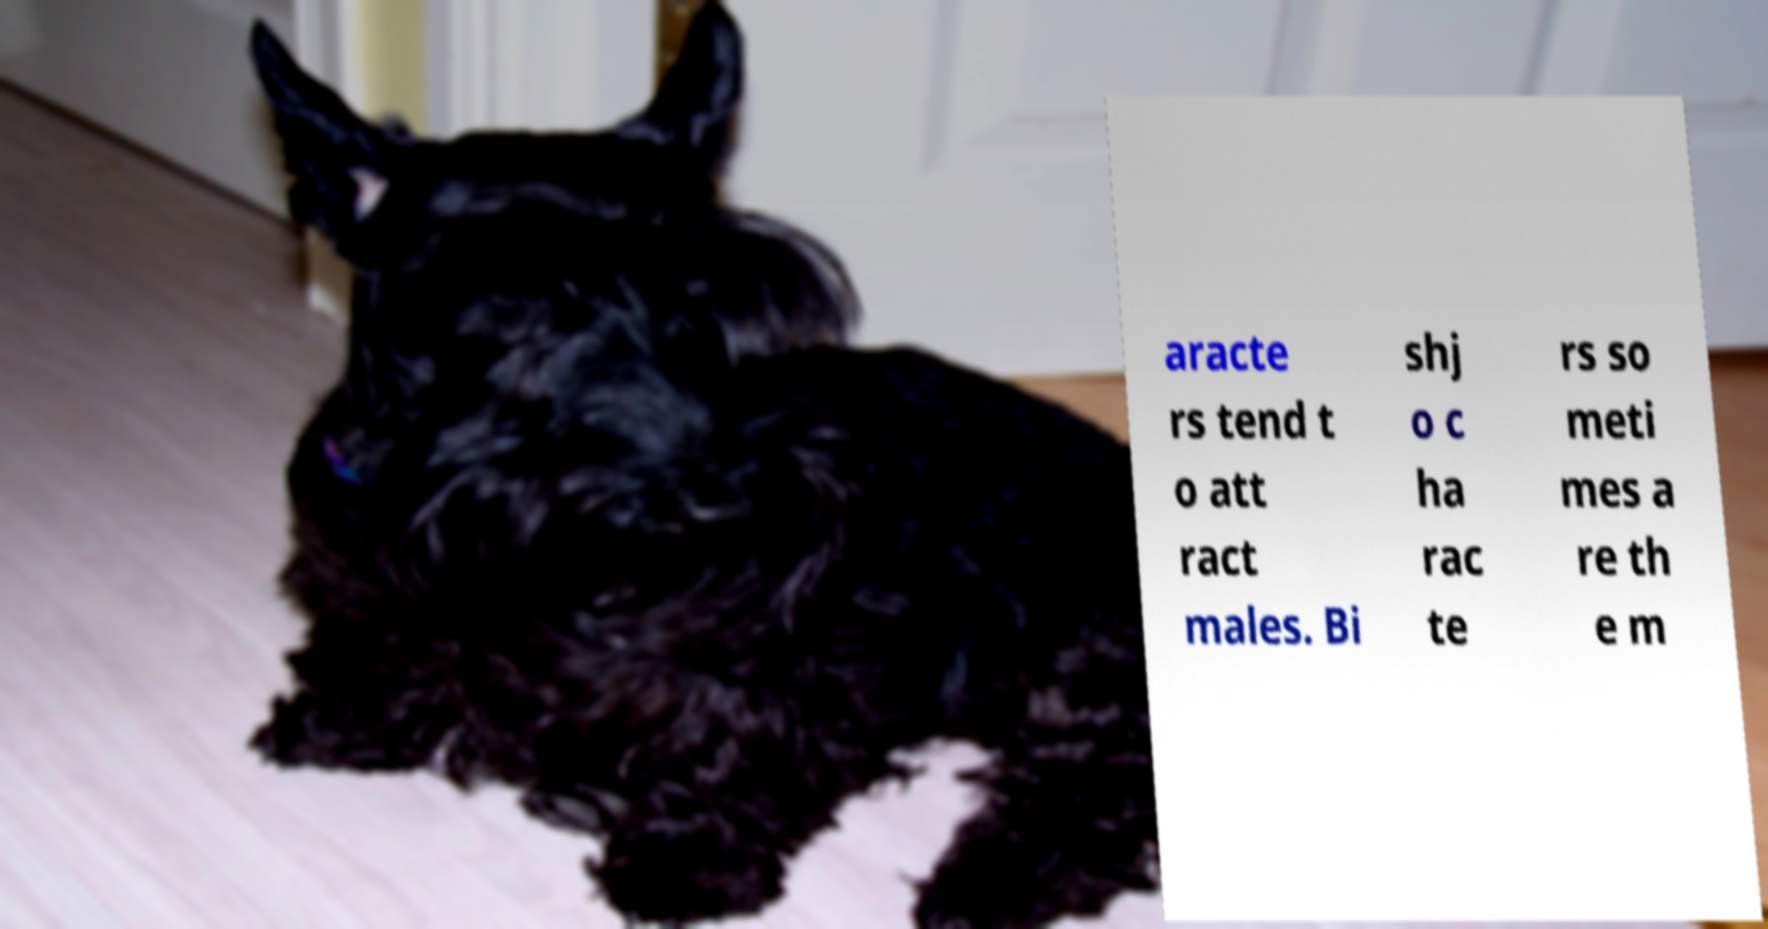Could you extract and type out the text from this image? aracte rs tend t o att ract males. Bi shj o c ha rac te rs so meti mes a re th e m 